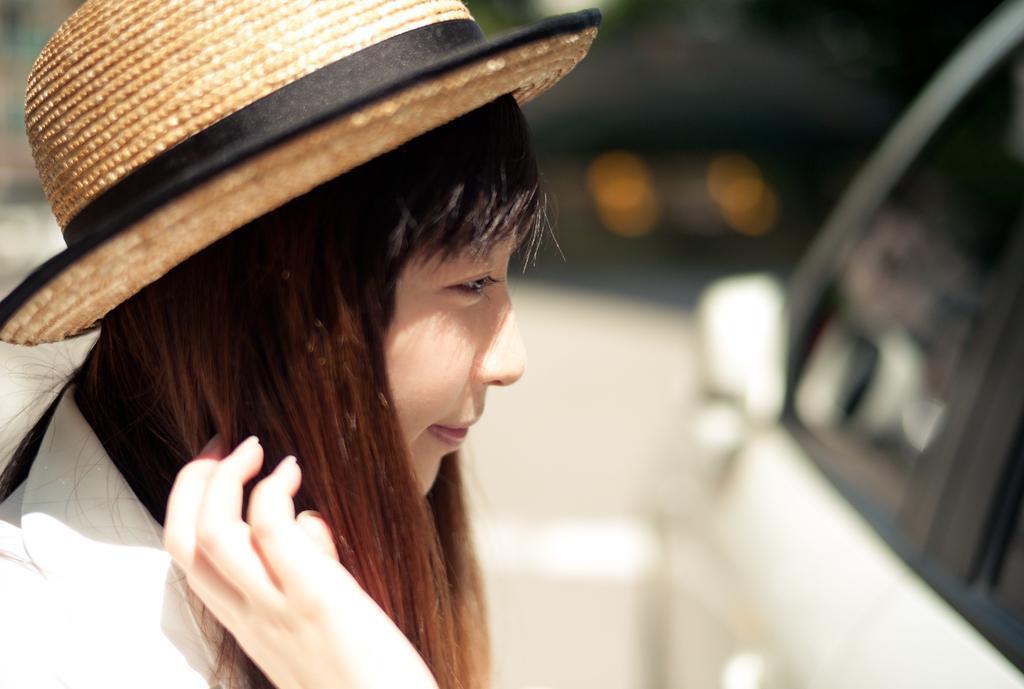How would you summarize this image in a sentence or two? There is one woman wearing a cap present on the left side of this image. There is a car on the right side of this image. 